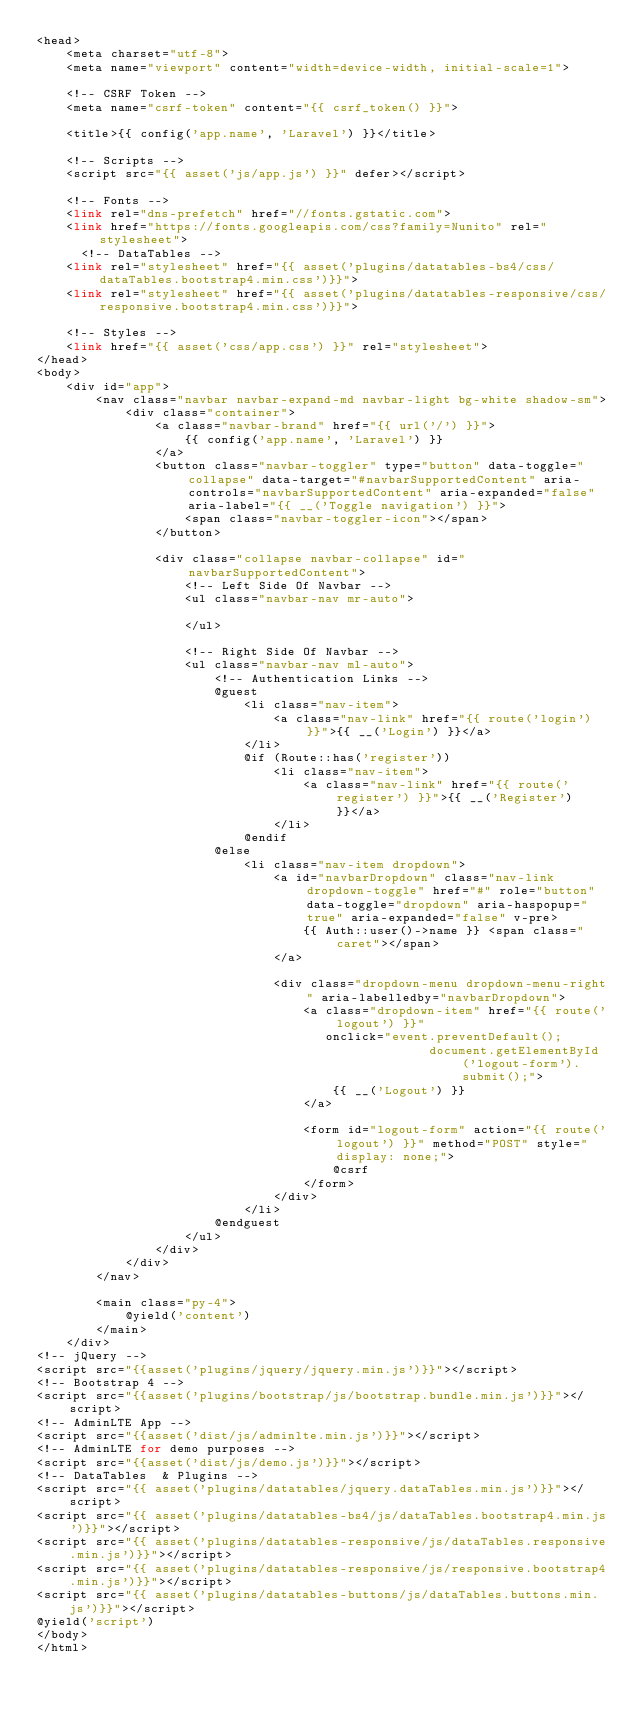<code> <loc_0><loc_0><loc_500><loc_500><_PHP_><head>
    <meta charset="utf-8">
    <meta name="viewport" content="width=device-width, initial-scale=1">

    <!-- CSRF Token -->
    <meta name="csrf-token" content="{{ csrf_token() }}">

    <title>{{ config('app.name', 'Laravel') }}</title>

    <!-- Scripts -->
    <script src="{{ asset('js/app.js') }}" defer></script>

    <!-- Fonts -->
    <link rel="dns-prefetch" href="//fonts.gstatic.com">
    <link href="https://fonts.googleapis.com/css?family=Nunito" rel="stylesheet">
      <!-- DataTables -->
    <link rel="stylesheet" href="{{ asset('plugins/datatables-bs4/css/dataTables.bootstrap4.min.css')}}">
    <link rel="stylesheet" href="{{ asset('plugins/datatables-responsive/css/responsive.bootstrap4.min.css')}}">

    <!-- Styles -->
    <link href="{{ asset('css/app.css') }}" rel="stylesheet">
</head>
<body>
    <div id="app">
        <nav class="navbar navbar-expand-md navbar-light bg-white shadow-sm">
            <div class="container">
                <a class="navbar-brand" href="{{ url('/') }}">
                    {{ config('app.name', 'Laravel') }}
                </a>
                <button class="navbar-toggler" type="button" data-toggle="collapse" data-target="#navbarSupportedContent" aria-controls="navbarSupportedContent" aria-expanded="false" aria-label="{{ __('Toggle navigation') }}">
                    <span class="navbar-toggler-icon"></span>
                </button>

                <div class="collapse navbar-collapse" id="navbarSupportedContent">
                    <!-- Left Side Of Navbar -->
                    <ul class="navbar-nav mr-auto">

                    </ul>

                    <!-- Right Side Of Navbar -->
                    <ul class="navbar-nav ml-auto">
                        <!-- Authentication Links -->
                        @guest
                            <li class="nav-item">
                                <a class="nav-link" href="{{ route('login') }}">{{ __('Login') }}</a>
                            </li>
                            @if (Route::has('register'))
                                <li class="nav-item">
                                    <a class="nav-link" href="{{ route('register') }}">{{ __('Register') }}</a>
                                </li>
                            @endif
                        @else
                            <li class="nav-item dropdown">
                                <a id="navbarDropdown" class="nav-link dropdown-toggle" href="#" role="button" data-toggle="dropdown" aria-haspopup="true" aria-expanded="false" v-pre>
                                    {{ Auth::user()->name }} <span class="caret"></span>
                                </a>

                                <div class="dropdown-menu dropdown-menu-right" aria-labelledby="navbarDropdown">
                                    <a class="dropdown-item" href="{{ route('logout') }}"
                                       onclick="event.preventDefault();
                                                     document.getElementById('logout-form').submit();">
                                        {{ __('Logout') }}
                                    </a>

                                    <form id="logout-form" action="{{ route('logout') }}" method="POST" style="display: none;">
                                        @csrf
                                    </form>
                                </div>
                            </li>
                        @endguest
                    </ul>
                </div>
            </div>
        </nav>

        <main class="py-4">
            @yield('content')
        </main>
    </div>
<!-- jQuery -->
<script src="{{asset('plugins/jquery/jquery.min.js')}}"></script>
<!-- Bootstrap 4 -->
<script src="{{asset('plugins/bootstrap/js/bootstrap.bundle.min.js')}}"></script>
<!-- AdminLTE App -->
<script src="{{asset('dist/js/adminlte.min.js')}}"></script>
<!-- AdminLTE for demo purposes -->
<script src="{{asset('dist/js/demo.js')}}"></script>
<!-- DataTables  & Plugins -->
<script src="{{ asset('plugins/datatables/jquery.dataTables.min.js')}}"></script>
<script src="{{ asset('plugins/datatables-bs4/js/dataTables.bootstrap4.min.js')}}"></script>
<script src="{{ asset('plugins/datatables-responsive/js/dataTables.responsive.min.js')}}"></script>
<script src="{{ asset('plugins/datatables-responsive/js/responsive.bootstrap4.min.js')}}"></script>
<script src="{{ asset('plugins/datatables-buttons/js/dataTables.buttons.min.js')}}"></script>
@yield('script')
</body>
</html>
</code> 